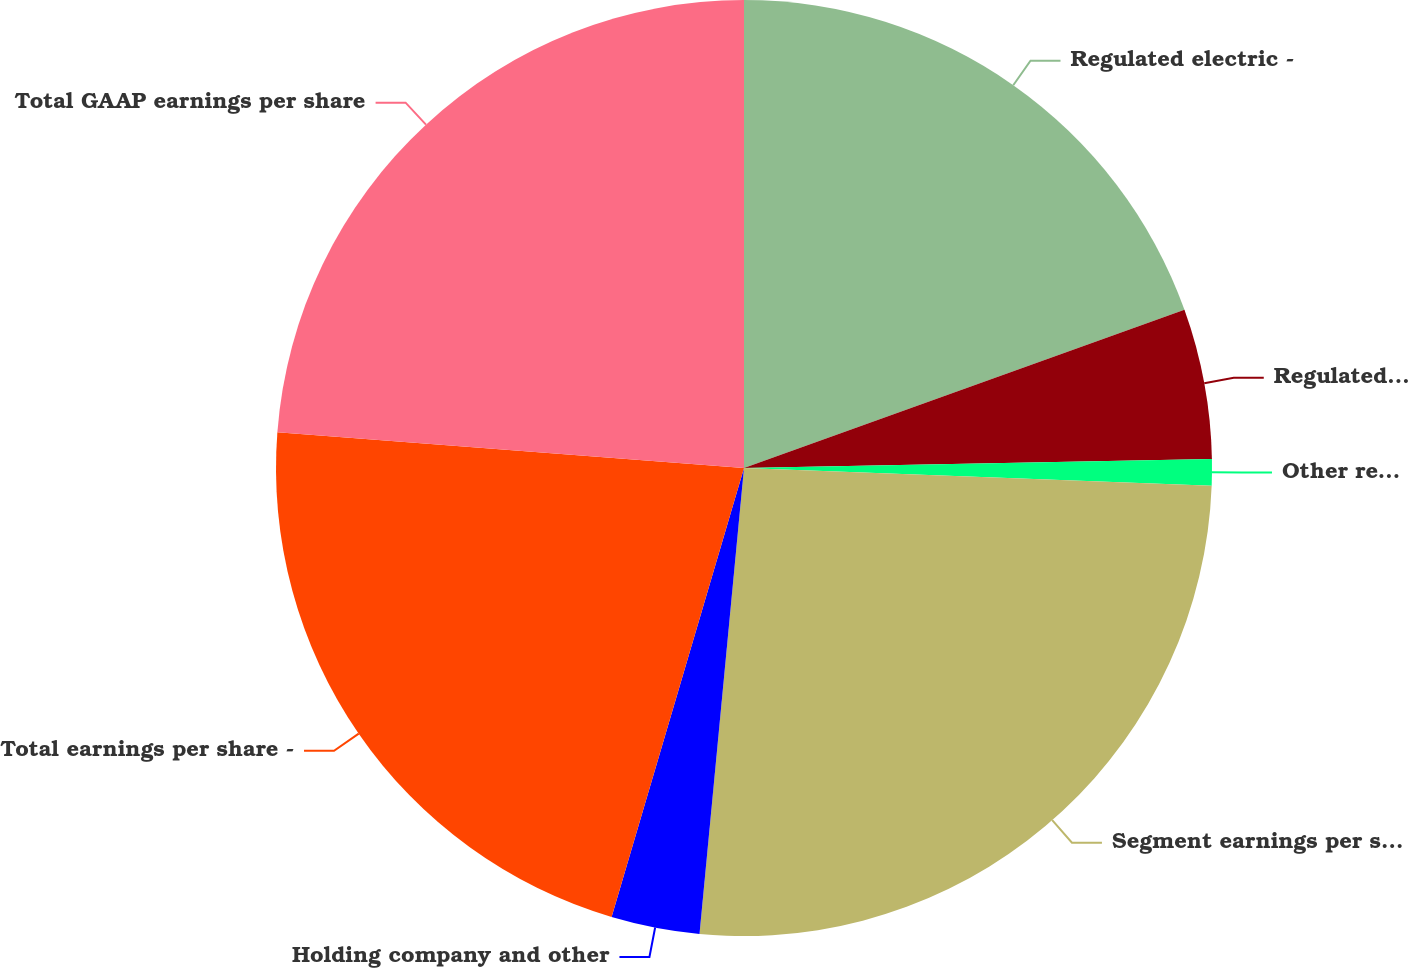Convert chart to OTSL. <chart><loc_0><loc_0><loc_500><loc_500><pie_chart><fcel>Regulated electric -<fcel>Regulated natural gas -<fcel>Other regulated income (a)<fcel>Segment earnings per share -<fcel>Holding company and other<fcel>Total earnings per share -<fcel>Total GAAP earnings per share<nl><fcel>19.51%<fcel>5.18%<fcel>0.91%<fcel>25.91%<fcel>3.05%<fcel>21.65%<fcel>23.78%<nl></chart> 